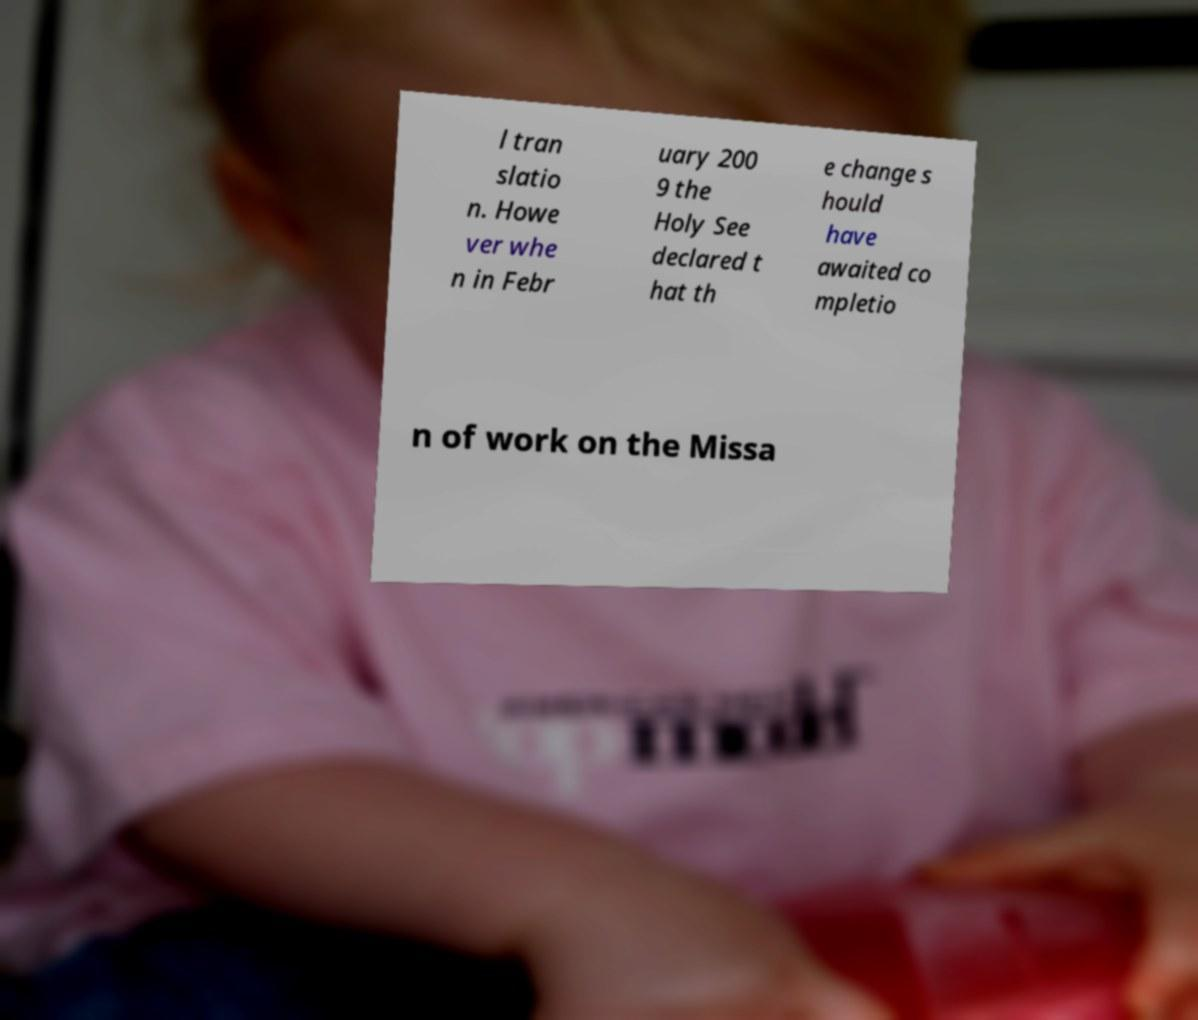Please identify and transcribe the text found in this image. l tran slatio n. Howe ver whe n in Febr uary 200 9 the Holy See declared t hat th e change s hould have awaited co mpletio n of work on the Missa 